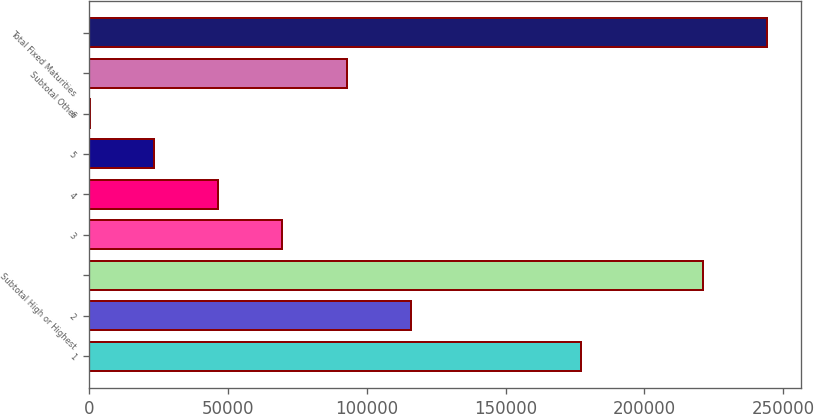<chart> <loc_0><loc_0><loc_500><loc_500><bar_chart><fcel>1<fcel>2<fcel>Subtotal High or Highest<fcel>3<fcel>4<fcel>5<fcel>6<fcel>Subtotal Other<fcel>Total Fixed Maturities<nl><fcel>177350<fcel>115824<fcel>221081<fcel>69640.9<fcel>46549.6<fcel>23458.3<fcel>367<fcel>92732.2<fcel>244172<nl></chart> 